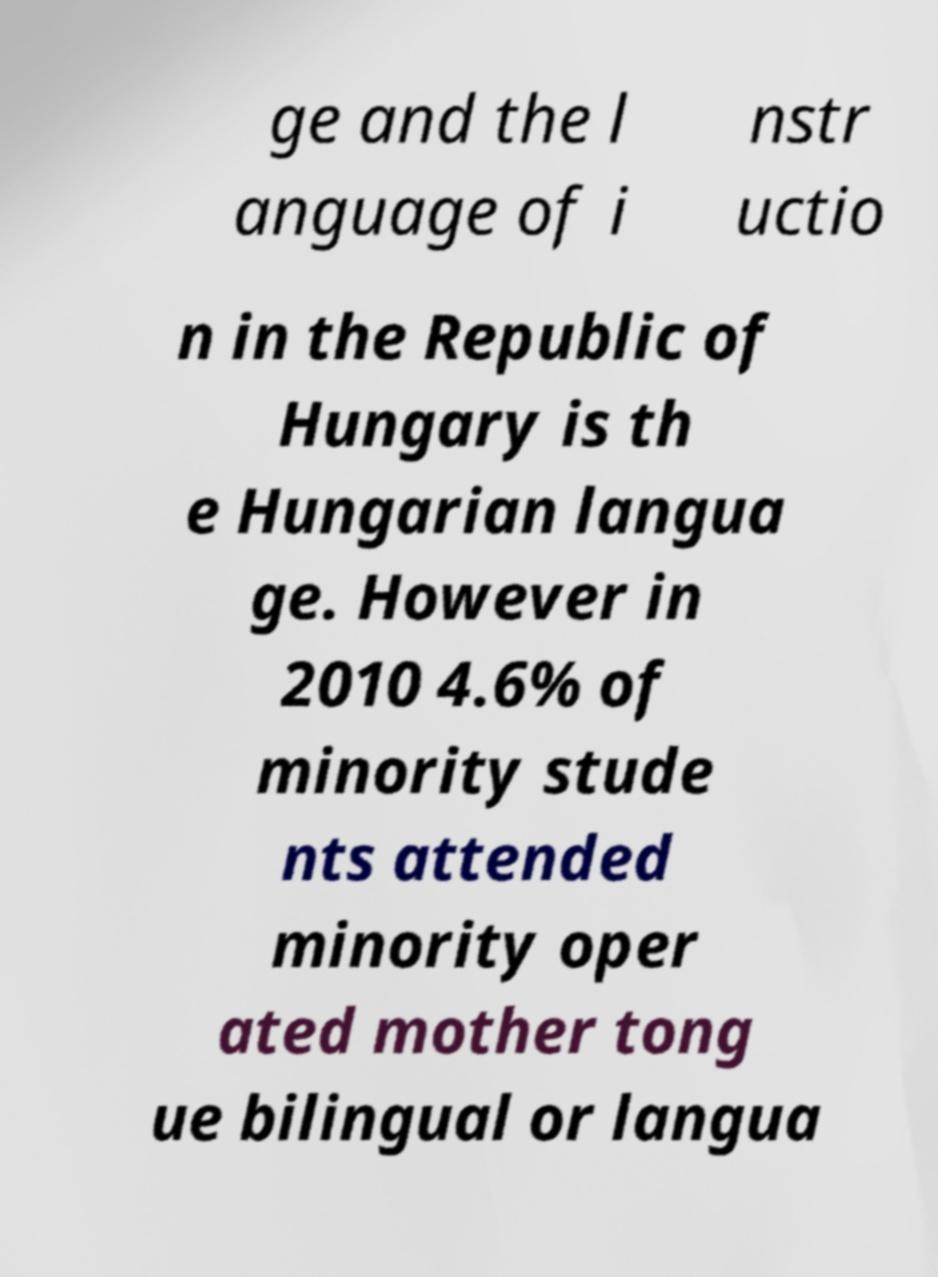Could you assist in decoding the text presented in this image and type it out clearly? ge and the l anguage of i nstr uctio n in the Republic of Hungary is th e Hungarian langua ge. However in 2010 4.6% of minority stude nts attended minority oper ated mother tong ue bilingual or langua 